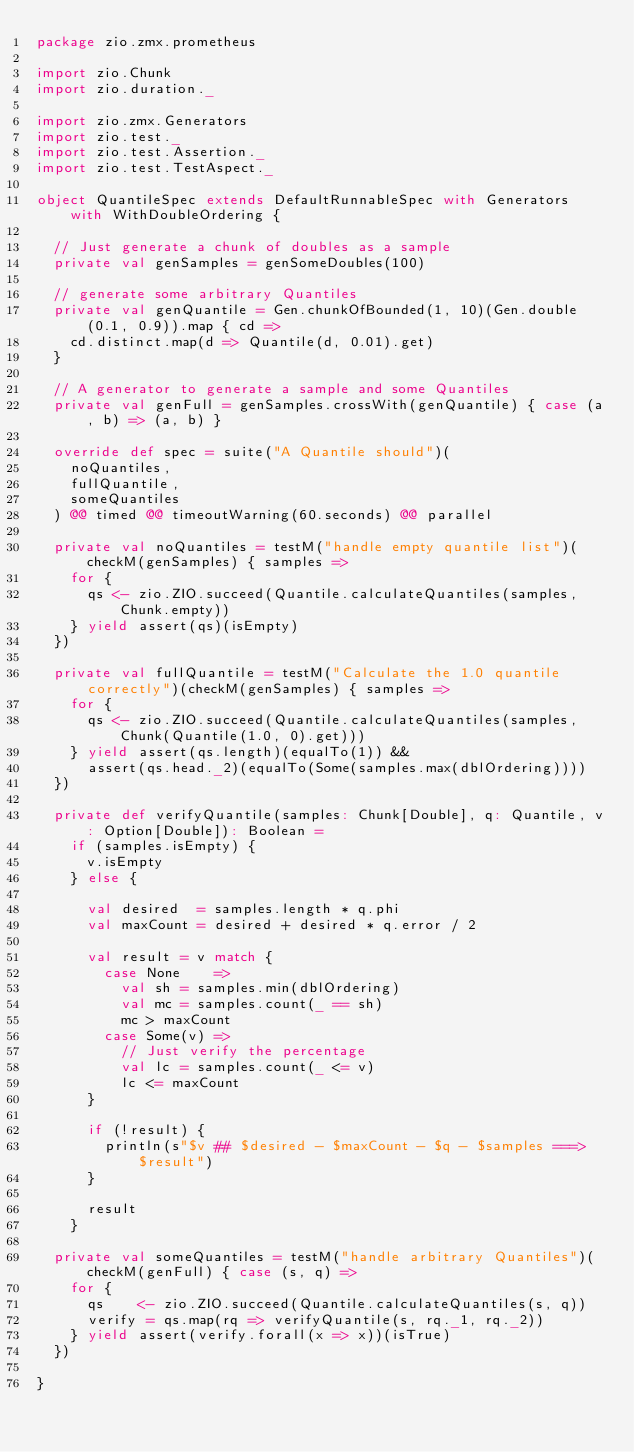<code> <loc_0><loc_0><loc_500><loc_500><_Scala_>package zio.zmx.prometheus

import zio.Chunk
import zio.duration._

import zio.zmx.Generators
import zio.test._
import zio.test.Assertion._
import zio.test.TestAspect._

object QuantileSpec extends DefaultRunnableSpec with Generators with WithDoubleOrdering {

  // Just generate a chunk of doubles as a sample
  private val genSamples = genSomeDoubles(100)

  // generate some arbitrary Quantiles
  private val genQuantile = Gen.chunkOfBounded(1, 10)(Gen.double(0.1, 0.9)).map { cd =>
    cd.distinct.map(d => Quantile(d, 0.01).get)
  }

  // A generator to generate a sample and some Quantiles
  private val genFull = genSamples.crossWith(genQuantile) { case (a, b) => (a, b) }

  override def spec = suite("A Quantile should")(
    noQuantiles,
    fullQuantile,
    someQuantiles
  ) @@ timed @@ timeoutWarning(60.seconds) @@ parallel

  private val noQuantiles = testM("handle empty quantile list")(checkM(genSamples) { samples =>
    for {
      qs <- zio.ZIO.succeed(Quantile.calculateQuantiles(samples, Chunk.empty))
    } yield assert(qs)(isEmpty)
  })

  private val fullQuantile = testM("Calculate the 1.0 quantile correctly")(checkM(genSamples) { samples =>
    for {
      qs <- zio.ZIO.succeed(Quantile.calculateQuantiles(samples, Chunk(Quantile(1.0, 0).get)))
    } yield assert(qs.length)(equalTo(1)) &&
      assert(qs.head._2)(equalTo(Some(samples.max(dblOrdering))))
  })

  private def verifyQuantile(samples: Chunk[Double], q: Quantile, v: Option[Double]): Boolean =
    if (samples.isEmpty) {
      v.isEmpty
    } else {

      val desired  = samples.length * q.phi
      val maxCount = desired + desired * q.error / 2

      val result = v match {
        case None    =>
          val sh = samples.min(dblOrdering)
          val mc = samples.count(_ == sh)
          mc > maxCount
        case Some(v) =>
          // Just verify the percentage
          val lc = samples.count(_ <= v)
          lc <= maxCount
      }

      if (!result) {
        println(s"$v ## $desired - $maxCount - $q - $samples ===> $result")
      }

      result
    }

  private val someQuantiles = testM("handle arbitrary Quantiles")(checkM(genFull) { case (s, q) =>
    for {
      qs    <- zio.ZIO.succeed(Quantile.calculateQuantiles(s, q))
      verify = qs.map(rq => verifyQuantile(s, rq._1, rq._2))
    } yield assert(verify.forall(x => x))(isTrue)
  })

}
</code> 